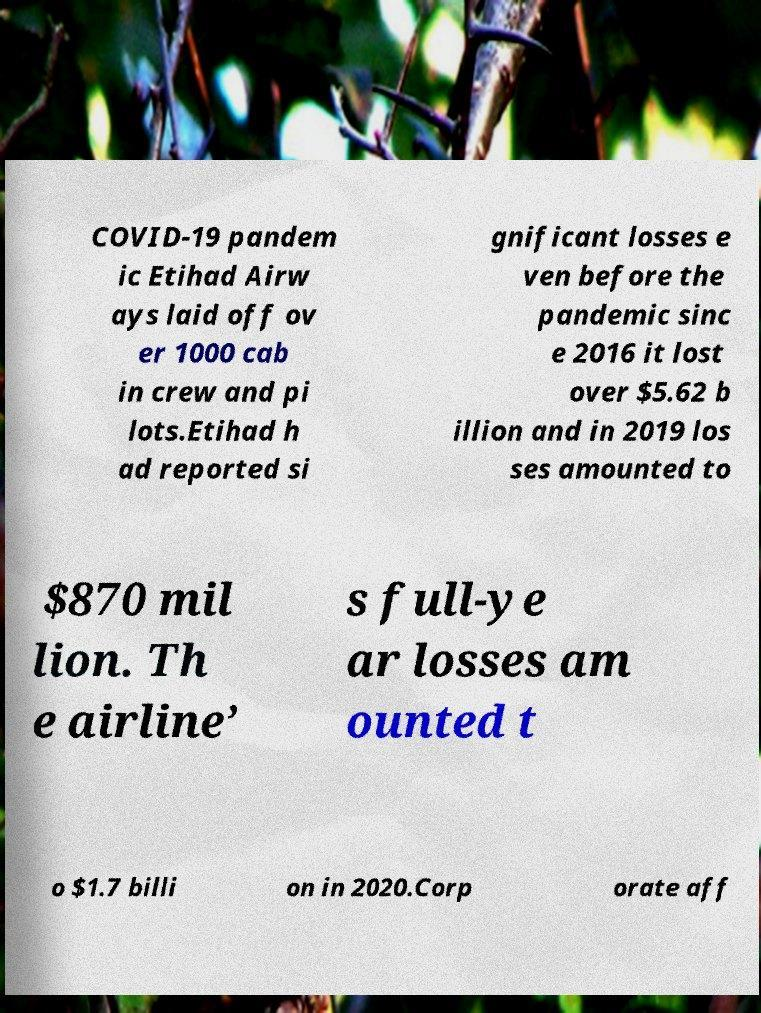Please read and relay the text visible in this image. What does it say? COVID-19 pandem ic Etihad Airw ays laid off ov er 1000 cab in crew and pi lots.Etihad h ad reported si gnificant losses e ven before the pandemic sinc e 2016 it lost over $5.62 b illion and in 2019 los ses amounted to $870 mil lion. Th e airline’ s full-ye ar losses am ounted t o $1.7 billi on in 2020.Corp orate aff 